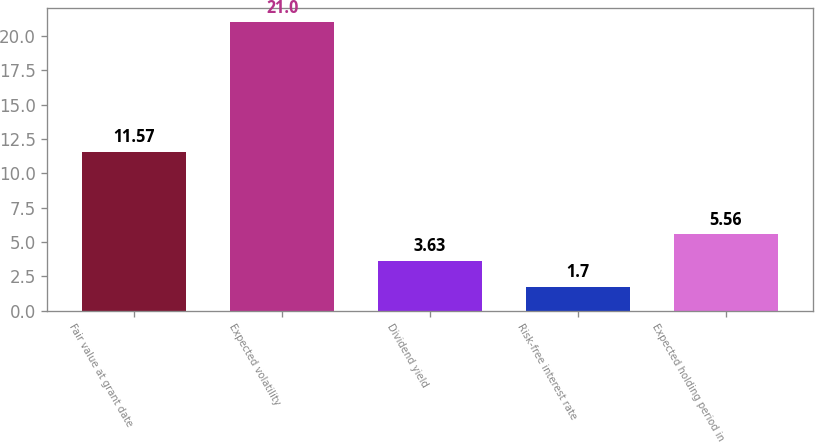Convert chart. <chart><loc_0><loc_0><loc_500><loc_500><bar_chart><fcel>Fair value at grant date<fcel>Expected volatility<fcel>Dividend yield<fcel>Risk-free interest rate<fcel>Expected holding period in<nl><fcel>11.57<fcel>21<fcel>3.63<fcel>1.7<fcel>5.56<nl></chart> 